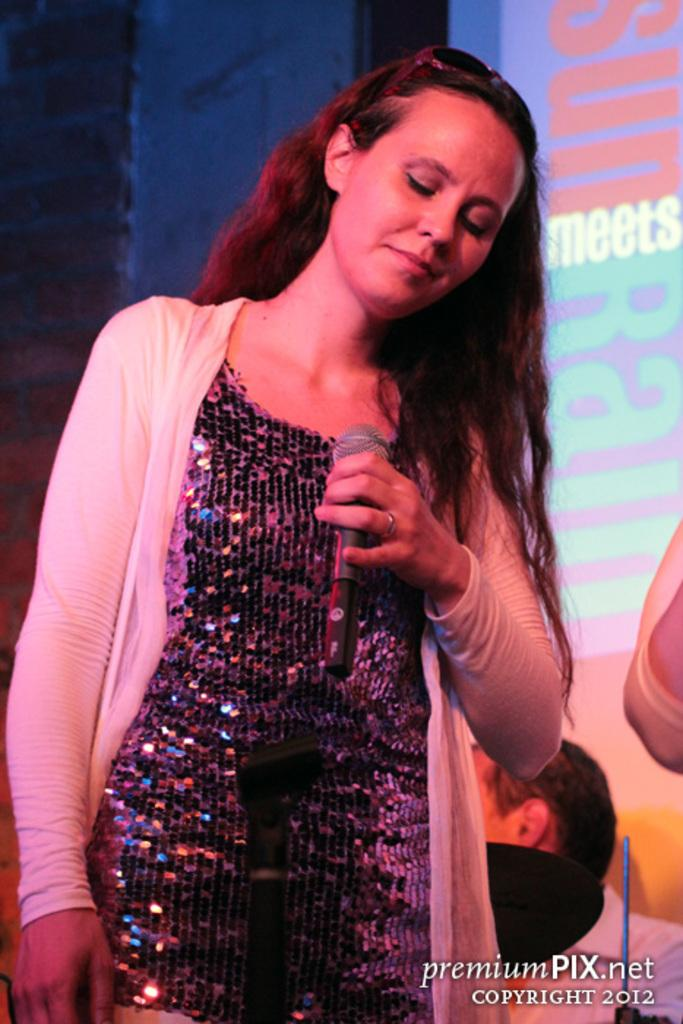Who is the main subject in the image? There is a woman in the image. What is the woman holding in her hand? The woman is holding a mic in her hand. What is the woman wearing? The woman is wearing a white cardigan. What can be seen in the background of the image? There is a projector screen in the background of the image. What is displayed on the projector screen? The projector screen is displaying something. How does the woman contribute to reducing pollution in the image? There is no information about pollution or the woman's actions to reduce it in the image. 